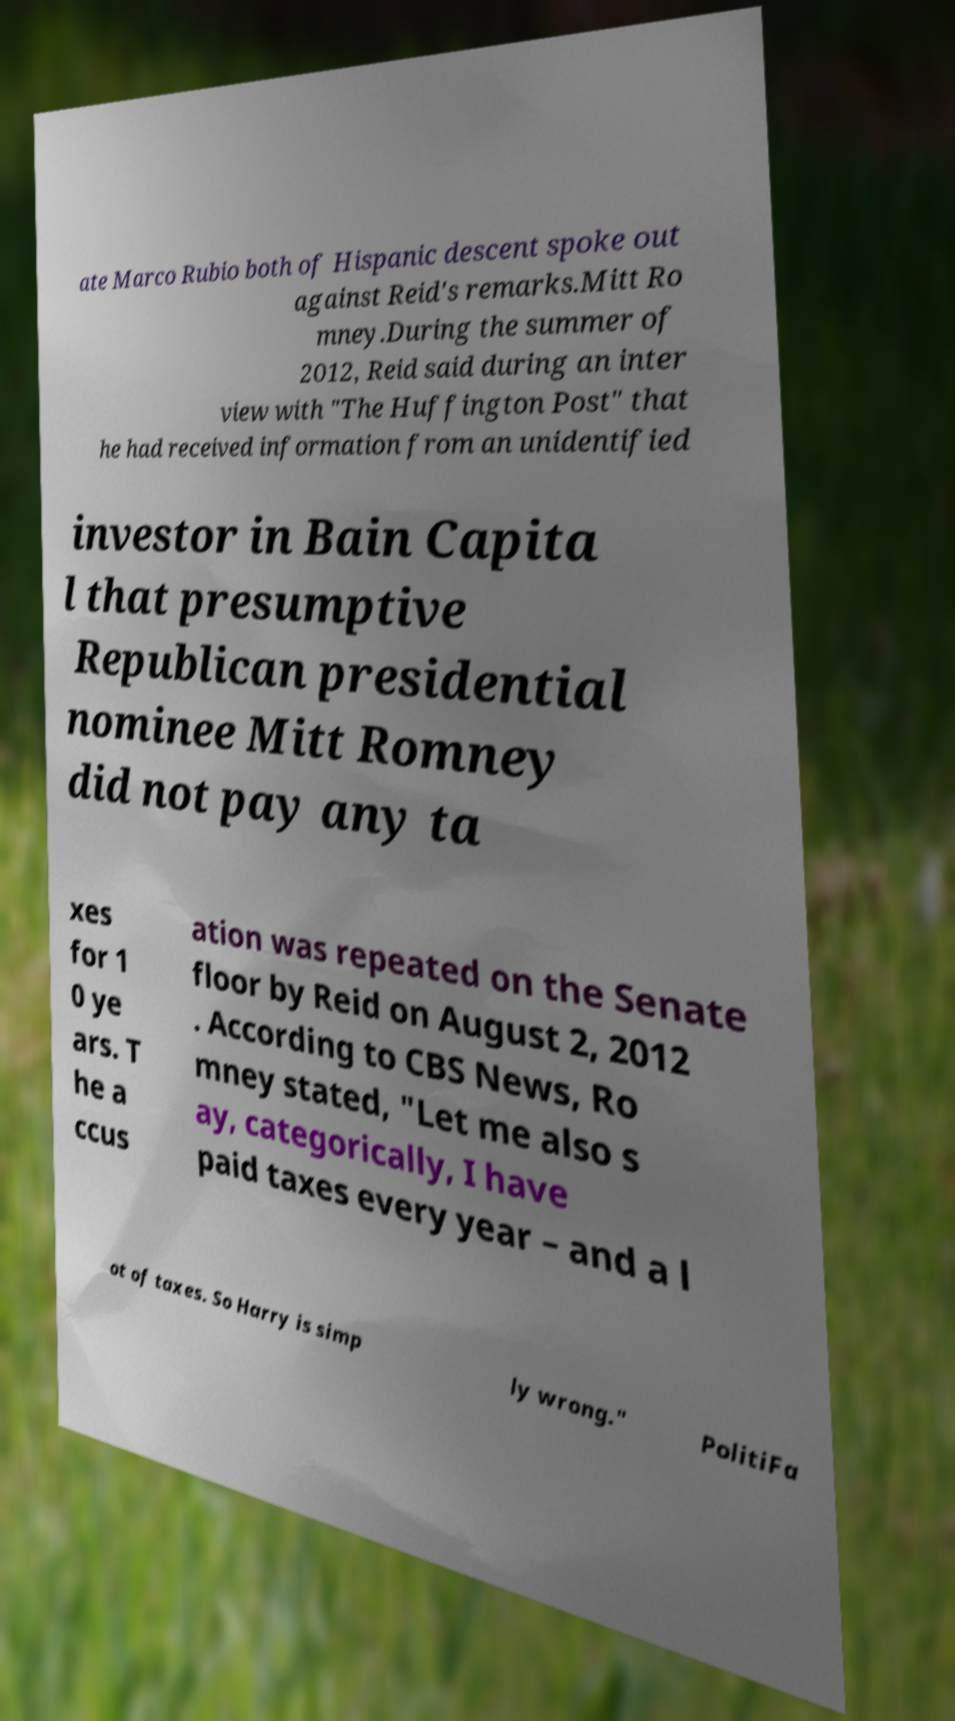I need the written content from this picture converted into text. Can you do that? ate Marco Rubio both of Hispanic descent spoke out against Reid's remarks.Mitt Ro mney.During the summer of 2012, Reid said during an inter view with "The Huffington Post" that he had received information from an unidentified investor in Bain Capita l that presumptive Republican presidential nominee Mitt Romney did not pay any ta xes for 1 0 ye ars. T he a ccus ation was repeated on the Senate floor by Reid on August 2, 2012 . According to CBS News, Ro mney stated, "Let me also s ay, categorically, I have paid taxes every year – and a l ot of taxes. So Harry is simp ly wrong." PolitiFa 